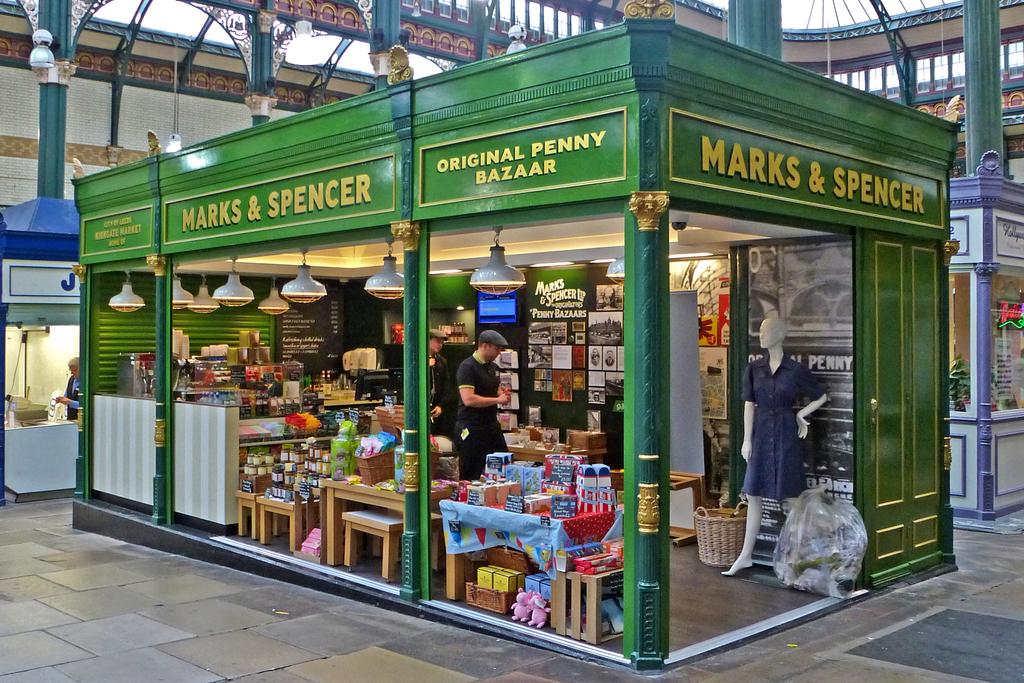What is the name of the store?
Offer a terse response. Marks & spencer. What currency denomination is specified on the sign?
Provide a succinct answer. Penny. 